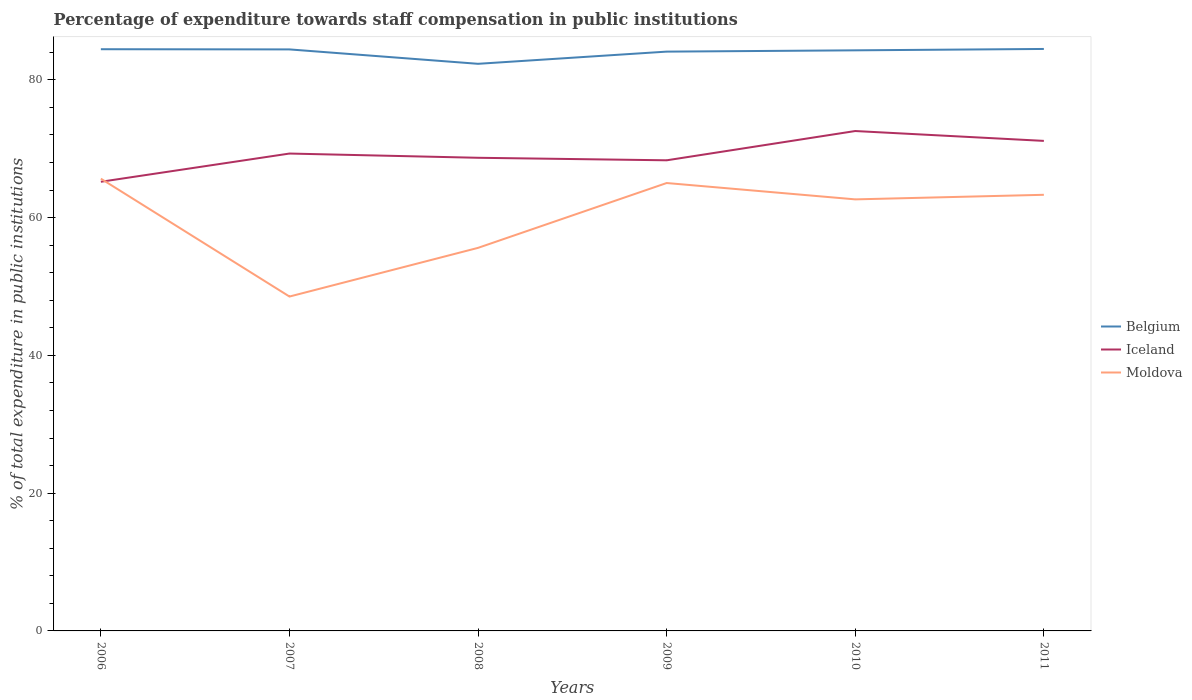How many different coloured lines are there?
Your answer should be compact. 3. Across all years, what is the maximum percentage of expenditure towards staff compensation in Belgium?
Provide a succinct answer. 82.33. In which year was the percentage of expenditure towards staff compensation in Belgium maximum?
Your answer should be very brief. 2008. What is the total percentage of expenditure towards staff compensation in Belgium in the graph?
Offer a very short reply. 0.14. What is the difference between the highest and the second highest percentage of expenditure towards staff compensation in Moldova?
Keep it short and to the point. 17.11. Is the percentage of expenditure towards staff compensation in Iceland strictly greater than the percentage of expenditure towards staff compensation in Belgium over the years?
Offer a terse response. Yes. How many years are there in the graph?
Your response must be concise. 6. Where does the legend appear in the graph?
Your answer should be very brief. Center right. How many legend labels are there?
Offer a very short reply. 3. What is the title of the graph?
Your response must be concise. Percentage of expenditure towards staff compensation in public institutions. Does "Tuvalu" appear as one of the legend labels in the graph?
Keep it short and to the point. No. What is the label or title of the X-axis?
Ensure brevity in your answer.  Years. What is the label or title of the Y-axis?
Give a very brief answer. % of total expenditure in public institutions. What is the % of total expenditure in public institutions in Belgium in 2006?
Make the answer very short. 84.45. What is the % of total expenditure in public institutions in Iceland in 2006?
Keep it short and to the point. 65.2. What is the % of total expenditure in public institutions of Moldova in 2006?
Your response must be concise. 65.65. What is the % of total expenditure in public institutions in Belgium in 2007?
Provide a succinct answer. 84.42. What is the % of total expenditure in public institutions of Iceland in 2007?
Offer a terse response. 69.3. What is the % of total expenditure in public institutions of Moldova in 2007?
Ensure brevity in your answer.  48.54. What is the % of total expenditure in public institutions in Belgium in 2008?
Provide a succinct answer. 82.33. What is the % of total expenditure in public institutions in Iceland in 2008?
Keep it short and to the point. 68.69. What is the % of total expenditure in public institutions of Moldova in 2008?
Your response must be concise. 55.61. What is the % of total expenditure in public institutions in Belgium in 2009?
Ensure brevity in your answer.  84.1. What is the % of total expenditure in public institutions in Iceland in 2009?
Provide a succinct answer. 68.32. What is the % of total expenditure in public institutions in Moldova in 2009?
Your response must be concise. 65.02. What is the % of total expenditure in public institutions of Belgium in 2010?
Provide a succinct answer. 84.28. What is the % of total expenditure in public institutions in Iceland in 2010?
Your answer should be very brief. 72.57. What is the % of total expenditure in public institutions of Moldova in 2010?
Ensure brevity in your answer.  62.65. What is the % of total expenditure in public institutions of Belgium in 2011?
Make the answer very short. 84.48. What is the % of total expenditure in public institutions in Iceland in 2011?
Your response must be concise. 71.14. What is the % of total expenditure in public institutions of Moldova in 2011?
Make the answer very short. 63.31. Across all years, what is the maximum % of total expenditure in public institutions in Belgium?
Provide a succinct answer. 84.48. Across all years, what is the maximum % of total expenditure in public institutions of Iceland?
Your answer should be compact. 72.57. Across all years, what is the maximum % of total expenditure in public institutions in Moldova?
Provide a short and direct response. 65.65. Across all years, what is the minimum % of total expenditure in public institutions in Belgium?
Your response must be concise. 82.33. Across all years, what is the minimum % of total expenditure in public institutions of Iceland?
Keep it short and to the point. 65.2. Across all years, what is the minimum % of total expenditure in public institutions of Moldova?
Your answer should be very brief. 48.54. What is the total % of total expenditure in public institutions of Belgium in the graph?
Make the answer very short. 504.05. What is the total % of total expenditure in public institutions in Iceland in the graph?
Offer a very short reply. 415.22. What is the total % of total expenditure in public institutions in Moldova in the graph?
Offer a very short reply. 360.78. What is the difference between the % of total expenditure in public institutions of Belgium in 2006 and that in 2007?
Give a very brief answer. 0.03. What is the difference between the % of total expenditure in public institutions in Iceland in 2006 and that in 2007?
Ensure brevity in your answer.  -4.1. What is the difference between the % of total expenditure in public institutions in Moldova in 2006 and that in 2007?
Ensure brevity in your answer.  17.11. What is the difference between the % of total expenditure in public institutions of Belgium in 2006 and that in 2008?
Offer a very short reply. 2.12. What is the difference between the % of total expenditure in public institutions in Iceland in 2006 and that in 2008?
Make the answer very short. -3.48. What is the difference between the % of total expenditure in public institutions in Moldova in 2006 and that in 2008?
Give a very brief answer. 10.04. What is the difference between the % of total expenditure in public institutions in Belgium in 2006 and that in 2009?
Give a very brief answer. 0.35. What is the difference between the % of total expenditure in public institutions in Iceland in 2006 and that in 2009?
Keep it short and to the point. -3.12. What is the difference between the % of total expenditure in public institutions of Moldova in 2006 and that in 2009?
Keep it short and to the point. 0.63. What is the difference between the % of total expenditure in public institutions of Belgium in 2006 and that in 2010?
Give a very brief answer. 0.16. What is the difference between the % of total expenditure in public institutions in Iceland in 2006 and that in 2010?
Your answer should be compact. -7.37. What is the difference between the % of total expenditure in public institutions in Moldova in 2006 and that in 2010?
Make the answer very short. 3. What is the difference between the % of total expenditure in public institutions in Belgium in 2006 and that in 2011?
Your answer should be compact. -0.04. What is the difference between the % of total expenditure in public institutions of Iceland in 2006 and that in 2011?
Your answer should be compact. -5.93. What is the difference between the % of total expenditure in public institutions in Moldova in 2006 and that in 2011?
Make the answer very short. 2.34. What is the difference between the % of total expenditure in public institutions in Belgium in 2007 and that in 2008?
Give a very brief answer. 2.09. What is the difference between the % of total expenditure in public institutions in Iceland in 2007 and that in 2008?
Offer a very short reply. 0.61. What is the difference between the % of total expenditure in public institutions in Moldova in 2007 and that in 2008?
Give a very brief answer. -7.07. What is the difference between the % of total expenditure in public institutions in Belgium in 2007 and that in 2009?
Give a very brief answer. 0.32. What is the difference between the % of total expenditure in public institutions of Iceland in 2007 and that in 2009?
Offer a very short reply. 0.98. What is the difference between the % of total expenditure in public institutions in Moldova in 2007 and that in 2009?
Provide a short and direct response. -16.48. What is the difference between the % of total expenditure in public institutions of Belgium in 2007 and that in 2010?
Your answer should be very brief. 0.14. What is the difference between the % of total expenditure in public institutions in Iceland in 2007 and that in 2010?
Offer a terse response. -3.27. What is the difference between the % of total expenditure in public institutions of Moldova in 2007 and that in 2010?
Your answer should be compact. -14.11. What is the difference between the % of total expenditure in public institutions of Belgium in 2007 and that in 2011?
Provide a short and direct response. -0.07. What is the difference between the % of total expenditure in public institutions in Iceland in 2007 and that in 2011?
Give a very brief answer. -1.84. What is the difference between the % of total expenditure in public institutions in Moldova in 2007 and that in 2011?
Provide a succinct answer. -14.77. What is the difference between the % of total expenditure in public institutions in Belgium in 2008 and that in 2009?
Offer a very short reply. -1.77. What is the difference between the % of total expenditure in public institutions in Iceland in 2008 and that in 2009?
Your answer should be very brief. 0.37. What is the difference between the % of total expenditure in public institutions in Moldova in 2008 and that in 2009?
Keep it short and to the point. -9.41. What is the difference between the % of total expenditure in public institutions of Belgium in 2008 and that in 2010?
Ensure brevity in your answer.  -1.96. What is the difference between the % of total expenditure in public institutions of Iceland in 2008 and that in 2010?
Provide a succinct answer. -3.88. What is the difference between the % of total expenditure in public institutions of Moldova in 2008 and that in 2010?
Your answer should be very brief. -7.04. What is the difference between the % of total expenditure in public institutions in Belgium in 2008 and that in 2011?
Your answer should be compact. -2.16. What is the difference between the % of total expenditure in public institutions of Iceland in 2008 and that in 2011?
Your answer should be compact. -2.45. What is the difference between the % of total expenditure in public institutions of Moldova in 2008 and that in 2011?
Your answer should be very brief. -7.7. What is the difference between the % of total expenditure in public institutions in Belgium in 2009 and that in 2010?
Provide a short and direct response. -0.19. What is the difference between the % of total expenditure in public institutions of Iceland in 2009 and that in 2010?
Provide a succinct answer. -4.25. What is the difference between the % of total expenditure in public institutions of Moldova in 2009 and that in 2010?
Your response must be concise. 2.37. What is the difference between the % of total expenditure in public institutions of Belgium in 2009 and that in 2011?
Provide a succinct answer. -0.39. What is the difference between the % of total expenditure in public institutions of Iceland in 2009 and that in 2011?
Keep it short and to the point. -2.82. What is the difference between the % of total expenditure in public institutions of Moldova in 2009 and that in 2011?
Make the answer very short. 1.71. What is the difference between the % of total expenditure in public institutions in Belgium in 2010 and that in 2011?
Offer a terse response. -0.2. What is the difference between the % of total expenditure in public institutions of Iceland in 2010 and that in 2011?
Ensure brevity in your answer.  1.43. What is the difference between the % of total expenditure in public institutions in Moldova in 2010 and that in 2011?
Give a very brief answer. -0.66. What is the difference between the % of total expenditure in public institutions of Belgium in 2006 and the % of total expenditure in public institutions of Iceland in 2007?
Provide a short and direct response. 15.15. What is the difference between the % of total expenditure in public institutions in Belgium in 2006 and the % of total expenditure in public institutions in Moldova in 2007?
Your answer should be compact. 35.9. What is the difference between the % of total expenditure in public institutions in Iceland in 2006 and the % of total expenditure in public institutions in Moldova in 2007?
Ensure brevity in your answer.  16.66. What is the difference between the % of total expenditure in public institutions of Belgium in 2006 and the % of total expenditure in public institutions of Iceland in 2008?
Your response must be concise. 15.76. What is the difference between the % of total expenditure in public institutions in Belgium in 2006 and the % of total expenditure in public institutions in Moldova in 2008?
Keep it short and to the point. 28.84. What is the difference between the % of total expenditure in public institutions of Iceland in 2006 and the % of total expenditure in public institutions of Moldova in 2008?
Ensure brevity in your answer.  9.59. What is the difference between the % of total expenditure in public institutions of Belgium in 2006 and the % of total expenditure in public institutions of Iceland in 2009?
Ensure brevity in your answer.  16.13. What is the difference between the % of total expenditure in public institutions in Belgium in 2006 and the % of total expenditure in public institutions in Moldova in 2009?
Your answer should be compact. 19.42. What is the difference between the % of total expenditure in public institutions of Iceland in 2006 and the % of total expenditure in public institutions of Moldova in 2009?
Your answer should be very brief. 0.18. What is the difference between the % of total expenditure in public institutions of Belgium in 2006 and the % of total expenditure in public institutions of Iceland in 2010?
Provide a short and direct response. 11.88. What is the difference between the % of total expenditure in public institutions of Belgium in 2006 and the % of total expenditure in public institutions of Moldova in 2010?
Ensure brevity in your answer.  21.8. What is the difference between the % of total expenditure in public institutions of Iceland in 2006 and the % of total expenditure in public institutions of Moldova in 2010?
Offer a very short reply. 2.56. What is the difference between the % of total expenditure in public institutions in Belgium in 2006 and the % of total expenditure in public institutions in Iceland in 2011?
Offer a terse response. 13.31. What is the difference between the % of total expenditure in public institutions in Belgium in 2006 and the % of total expenditure in public institutions in Moldova in 2011?
Provide a short and direct response. 21.13. What is the difference between the % of total expenditure in public institutions of Iceland in 2006 and the % of total expenditure in public institutions of Moldova in 2011?
Make the answer very short. 1.89. What is the difference between the % of total expenditure in public institutions in Belgium in 2007 and the % of total expenditure in public institutions in Iceland in 2008?
Make the answer very short. 15.73. What is the difference between the % of total expenditure in public institutions in Belgium in 2007 and the % of total expenditure in public institutions in Moldova in 2008?
Keep it short and to the point. 28.81. What is the difference between the % of total expenditure in public institutions of Iceland in 2007 and the % of total expenditure in public institutions of Moldova in 2008?
Make the answer very short. 13.69. What is the difference between the % of total expenditure in public institutions of Belgium in 2007 and the % of total expenditure in public institutions of Iceland in 2009?
Keep it short and to the point. 16.1. What is the difference between the % of total expenditure in public institutions in Belgium in 2007 and the % of total expenditure in public institutions in Moldova in 2009?
Offer a very short reply. 19.4. What is the difference between the % of total expenditure in public institutions in Iceland in 2007 and the % of total expenditure in public institutions in Moldova in 2009?
Provide a short and direct response. 4.28. What is the difference between the % of total expenditure in public institutions in Belgium in 2007 and the % of total expenditure in public institutions in Iceland in 2010?
Provide a succinct answer. 11.85. What is the difference between the % of total expenditure in public institutions of Belgium in 2007 and the % of total expenditure in public institutions of Moldova in 2010?
Keep it short and to the point. 21.77. What is the difference between the % of total expenditure in public institutions of Iceland in 2007 and the % of total expenditure in public institutions of Moldova in 2010?
Offer a terse response. 6.65. What is the difference between the % of total expenditure in public institutions in Belgium in 2007 and the % of total expenditure in public institutions in Iceland in 2011?
Make the answer very short. 13.28. What is the difference between the % of total expenditure in public institutions of Belgium in 2007 and the % of total expenditure in public institutions of Moldova in 2011?
Your answer should be compact. 21.11. What is the difference between the % of total expenditure in public institutions in Iceland in 2007 and the % of total expenditure in public institutions in Moldova in 2011?
Keep it short and to the point. 5.99. What is the difference between the % of total expenditure in public institutions in Belgium in 2008 and the % of total expenditure in public institutions in Iceland in 2009?
Provide a short and direct response. 14.01. What is the difference between the % of total expenditure in public institutions of Belgium in 2008 and the % of total expenditure in public institutions of Moldova in 2009?
Your response must be concise. 17.31. What is the difference between the % of total expenditure in public institutions in Iceland in 2008 and the % of total expenditure in public institutions in Moldova in 2009?
Keep it short and to the point. 3.66. What is the difference between the % of total expenditure in public institutions of Belgium in 2008 and the % of total expenditure in public institutions of Iceland in 2010?
Offer a terse response. 9.76. What is the difference between the % of total expenditure in public institutions of Belgium in 2008 and the % of total expenditure in public institutions of Moldova in 2010?
Provide a succinct answer. 19.68. What is the difference between the % of total expenditure in public institutions in Iceland in 2008 and the % of total expenditure in public institutions in Moldova in 2010?
Provide a succinct answer. 6.04. What is the difference between the % of total expenditure in public institutions in Belgium in 2008 and the % of total expenditure in public institutions in Iceland in 2011?
Your answer should be very brief. 11.19. What is the difference between the % of total expenditure in public institutions of Belgium in 2008 and the % of total expenditure in public institutions of Moldova in 2011?
Your response must be concise. 19.02. What is the difference between the % of total expenditure in public institutions of Iceland in 2008 and the % of total expenditure in public institutions of Moldova in 2011?
Make the answer very short. 5.37. What is the difference between the % of total expenditure in public institutions in Belgium in 2009 and the % of total expenditure in public institutions in Iceland in 2010?
Your response must be concise. 11.53. What is the difference between the % of total expenditure in public institutions in Belgium in 2009 and the % of total expenditure in public institutions in Moldova in 2010?
Keep it short and to the point. 21.45. What is the difference between the % of total expenditure in public institutions in Iceland in 2009 and the % of total expenditure in public institutions in Moldova in 2010?
Provide a short and direct response. 5.67. What is the difference between the % of total expenditure in public institutions of Belgium in 2009 and the % of total expenditure in public institutions of Iceland in 2011?
Keep it short and to the point. 12.96. What is the difference between the % of total expenditure in public institutions in Belgium in 2009 and the % of total expenditure in public institutions in Moldova in 2011?
Make the answer very short. 20.79. What is the difference between the % of total expenditure in public institutions of Iceland in 2009 and the % of total expenditure in public institutions of Moldova in 2011?
Offer a terse response. 5.01. What is the difference between the % of total expenditure in public institutions in Belgium in 2010 and the % of total expenditure in public institutions in Iceland in 2011?
Make the answer very short. 13.15. What is the difference between the % of total expenditure in public institutions in Belgium in 2010 and the % of total expenditure in public institutions in Moldova in 2011?
Your response must be concise. 20.97. What is the difference between the % of total expenditure in public institutions of Iceland in 2010 and the % of total expenditure in public institutions of Moldova in 2011?
Provide a succinct answer. 9.26. What is the average % of total expenditure in public institutions in Belgium per year?
Offer a very short reply. 84.01. What is the average % of total expenditure in public institutions in Iceland per year?
Ensure brevity in your answer.  69.2. What is the average % of total expenditure in public institutions of Moldova per year?
Your answer should be compact. 60.13. In the year 2006, what is the difference between the % of total expenditure in public institutions in Belgium and % of total expenditure in public institutions in Iceland?
Give a very brief answer. 19.24. In the year 2006, what is the difference between the % of total expenditure in public institutions of Belgium and % of total expenditure in public institutions of Moldova?
Provide a succinct answer. 18.79. In the year 2006, what is the difference between the % of total expenditure in public institutions in Iceland and % of total expenditure in public institutions in Moldova?
Keep it short and to the point. -0.45. In the year 2007, what is the difference between the % of total expenditure in public institutions in Belgium and % of total expenditure in public institutions in Iceland?
Keep it short and to the point. 15.12. In the year 2007, what is the difference between the % of total expenditure in public institutions in Belgium and % of total expenditure in public institutions in Moldova?
Provide a succinct answer. 35.88. In the year 2007, what is the difference between the % of total expenditure in public institutions in Iceland and % of total expenditure in public institutions in Moldova?
Provide a succinct answer. 20.76. In the year 2008, what is the difference between the % of total expenditure in public institutions in Belgium and % of total expenditure in public institutions in Iceland?
Offer a very short reply. 13.64. In the year 2008, what is the difference between the % of total expenditure in public institutions of Belgium and % of total expenditure in public institutions of Moldova?
Offer a terse response. 26.72. In the year 2008, what is the difference between the % of total expenditure in public institutions in Iceland and % of total expenditure in public institutions in Moldova?
Your answer should be compact. 13.08. In the year 2009, what is the difference between the % of total expenditure in public institutions in Belgium and % of total expenditure in public institutions in Iceland?
Your answer should be very brief. 15.78. In the year 2009, what is the difference between the % of total expenditure in public institutions in Belgium and % of total expenditure in public institutions in Moldova?
Ensure brevity in your answer.  19.08. In the year 2009, what is the difference between the % of total expenditure in public institutions of Iceland and % of total expenditure in public institutions of Moldova?
Give a very brief answer. 3.3. In the year 2010, what is the difference between the % of total expenditure in public institutions of Belgium and % of total expenditure in public institutions of Iceland?
Ensure brevity in your answer.  11.71. In the year 2010, what is the difference between the % of total expenditure in public institutions of Belgium and % of total expenditure in public institutions of Moldova?
Your response must be concise. 21.64. In the year 2010, what is the difference between the % of total expenditure in public institutions of Iceland and % of total expenditure in public institutions of Moldova?
Your answer should be very brief. 9.92. In the year 2011, what is the difference between the % of total expenditure in public institutions of Belgium and % of total expenditure in public institutions of Iceland?
Offer a very short reply. 13.35. In the year 2011, what is the difference between the % of total expenditure in public institutions of Belgium and % of total expenditure in public institutions of Moldova?
Ensure brevity in your answer.  21.17. In the year 2011, what is the difference between the % of total expenditure in public institutions in Iceland and % of total expenditure in public institutions in Moldova?
Make the answer very short. 7.83. What is the ratio of the % of total expenditure in public institutions of Iceland in 2006 to that in 2007?
Provide a succinct answer. 0.94. What is the ratio of the % of total expenditure in public institutions in Moldova in 2006 to that in 2007?
Your answer should be very brief. 1.35. What is the ratio of the % of total expenditure in public institutions in Belgium in 2006 to that in 2008?
Offer a very short reply. 1.03. What is the ratio of the % of total expenditure in public institutions in Iceland in 2006 to that in 2008?
Your answer should be very brief. 0.95. What is the ratio of the % of total expenditure in public institutions of Moldova in 2006 to that in 2008?
Your answer should be very brief. 1.18. What is the ratio of the % of total expenditure in public institutions of Belgium in 2006 to that in 2009?
Keep it short and to the point. 1. What is the ratio of the % of total expenditure in public institutions in Iceland in 2006 to that in 2009?
Keep it short and to the point. 0.95. What is the ratio of the % of total expenditure in public institutions of Moldova in 2006 to that in 2009?
Your answer should be very brief. 1.01. What is the ratio of the % of total expenditure in public institutions in Iceland in 2006 to that in 2010?
Offer a very short reply. 0.9. What is the ratio of the % of total expenditure in public institutions in Moldova in 2006 to that in 2010?
Make the answer very short. 1.05. What is the ratio of the % of total expenditure in public institutions in Belgium in 2006 to that in 2011?
Provide a succinct answer. 1. What is the ratio of the % of total expenditure in public institutions in Iceland in 2006 to that in 2011?
Your answer should be compact. 0.92. What is the ratio of the % of total expenditure in public institutions in Belgium in 2007 to that in 2008?
Keep it short and to the point. 1.03. What is the ratio of the % of total expenditure in public institutions in Iceland in 2007 to that in 2008?
Your response must be concise. 1.01. What is the ratio of the % of total expenditure in public institutions in Moldova in 2007 to that in 2008?
Your answer should be compact. 0.87. What is the ratio of the % of total expenditure in public institutions of Iceland in 2007 to that in 2009?
Ensure brevity in your answer.  1.01. What is the ratio of the % of total expenditure in public institutions in Moldova in 2007 to that in 2009?
Keep it short and to the point. 0.75. What is the ratio of the % of total expenditure in public institutions in Iceland in 2007 to that in 2010?
Your answer should be very brief. 0.95. What is the ratio of the % of total expenditure in public institutions in Moldova in 2007 to that in 2010?
Ensure brevity in your answer.  0.77. What is the ratio of the % of total expenditure in public institutions of Belgium in 2007 to that in 2011?
Your response must be concise. 1. What is the ratio of the % of total expenditure in public institutions of Iceland in 2007 to that in 2011?
Make the answer very short. 0.97. What is the ratio of the % of total expenditure in public institutions of Moldova in 2007 to that in 2011?
Keep it short and to the point. 0.77. What is the ratio of the % of total expenditure in public institutions of Belgium in 2008 to that in 2009?
Your answer should be very brief. 0.98. What is the ratio of the % of total expenditure in public institutions of Iceland in 2008 to that in 2009?
Offer a terse response. 1.01. What is the ratio of the % of total expenditure in public institutions in Moldova in 2008 to that in 2009?
Offer a very short reply. 0.86. What is the ratio of the % of total expenditure in public institutions of Belgium in 2008 to that in 2010?
Ensure brevity in your answer.  0.98. What is the ratio of the % of total expenditure in public institutions of Iceland in 2008 to that in 2010?
Give a very brief answer. 0.95. What is the ratio of the % of total expenditure in public institutions in Moldova in 2008 to that in 2010?
Your answer should be very brief. 0.89. What is the ratio of the % of total expenditure in public institutions of Belgium in 2008 to that in 2011?
Your answer should be compact. 0.97. What is the ratio of the % of total expenditure in public institutions of Iceland in 2008 to that in 2011?
Provide a succinct answer. 0.97. What is the ratio of the % of total expenditure in public institutions in Moldova in 2008 to that in 2011?
Offer a very short reply. 0.88. What is the ratio of the % of total expenditure in public institutions of Iceland in 2009 to that in 2010?
Offer a terse response. 0.94. What is the ratio of the % of total expenditure in public institutions of Moldova in 2009 to that in 2010?
Make the answer very short. 1.04. What is the ratio of the % of total expenditure in public institutions in Iceland in 2009 to that in 2011?
Ensure brevity in your answer.  0.96. What is the ratio of the % of total expenditure in public institutions in Iceland in 2010 to that in 2011?
Ensure brevity in your answer.  1.02. What is the ratio of the % of total expenditure in public institutions of Moldova in 2010 to that in 2011?
Offer a very short reply. 0.99. What is the difference between the highest and the second highest % of total expenditure in public institutions in Belgium?
Provide a short and direct response. 0.04. What is the difference between the highest and the second highest % of total expenditure in public institutions in Iceland?
Give a very brief answer. 1.43. What is the difference between the highest and the second highest % of total expenditure in public institutions of Moldova?
Provide a short and direct response. 0.63. What is the difference between the highest and the lowest % of total expenditure in public institutions in Belgium?
Provide a succinct answer. 2.16. What is the difference between the highest and the lowest % of total expenditure in public institutions of Iceland?
Provide a short and direct response. 7.37. What is the difference between the highest and the lowest % of total expenditure in public institutions in Moldova?
Give a very brief answer. 17.11. 